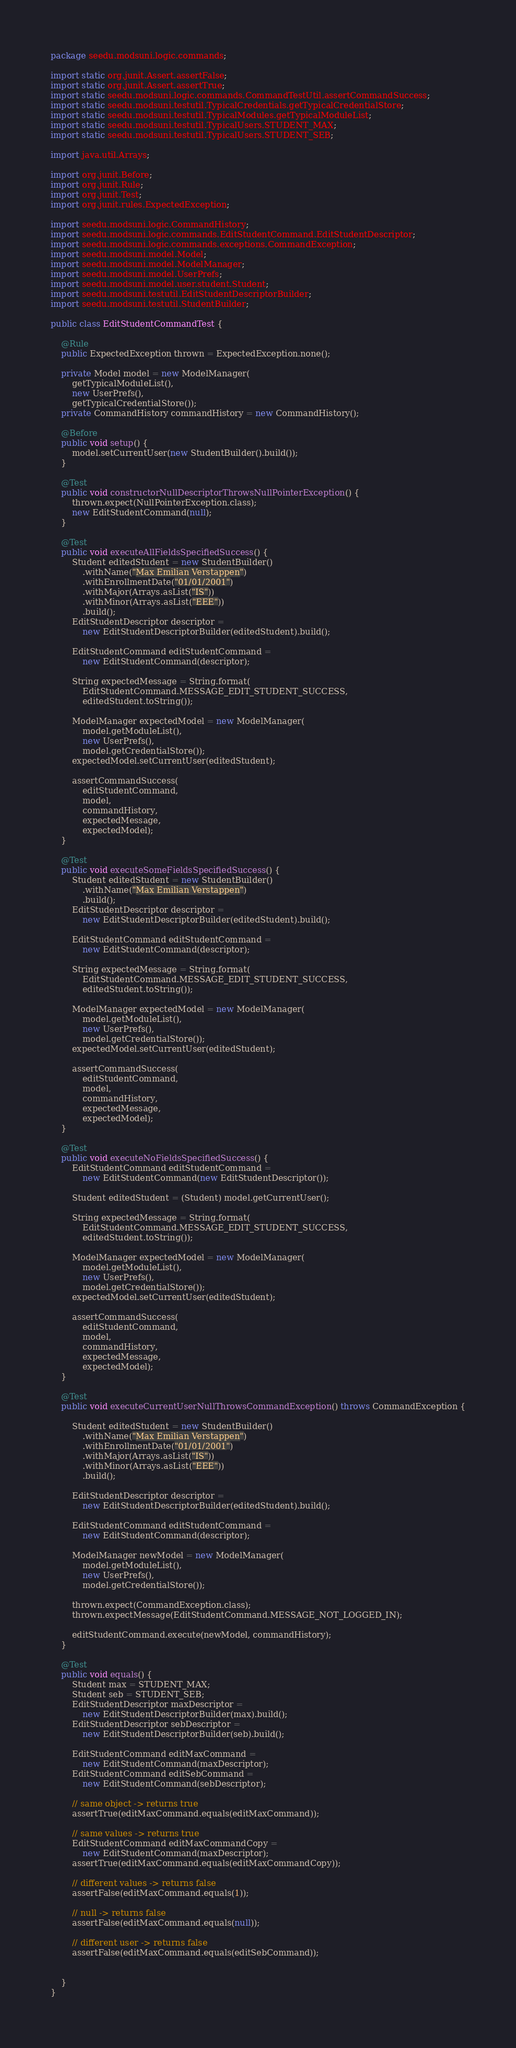Convert code to text. <code><loc_0><loc_0><loc_500><loc_500><_Java_>package seedu.modsuni.logic.commands;

import static org.junit.Assert.assertFalse;
import static org.junit.Assert.assertTrue;
import static seedu.modsuni.logic.commands.CommandTestUtil.assertCommandSuccess;
import static seedu.modsuni.testutil.TypicalCredentials.getTypicalCredentialStore;
import static seedu.modsuni.testutil.TypicalModules.getTypicalModuleList;
import static seedu.modsuni.testutil.TypicalUsers.STUDENT_MAX;
import static seedu.modsuni.testutil.TypicalUsers.STUDENT_SEB;

import java.util.Arrays;

import org.junit.Before;
import org.junit.Rule;
import org.junit.Test;
import org.junit.rules.ExpectedException;

import seedu.modsuni.logic.CommandHistory;
import seedu.modsuni.logic.commands.EditStudentCommand.EditStudentDescriptor;
import seedu.modsuni.logic.commands.exceptions.CommandException;
import seedu.modsuni.model.Model;
import seedu.modsuni.model.ModelManager;
import seedu.modsuni.model.UserPrefs;
import seedu.modsuni.model.user.student.Student;
import seedu.modsuni.testutil.EditStudentDescriptorBuilder;
import seedu.modsuni.testutil.StudentBuilder;

public class EditStudentCommandTest {

    @Rule
    public ExpectedException thrown = ExpectedException.none();

    private Model model = new ModelManager(
        getTypicalModuleList(),
        new UserPrefs(),
        getTypicalCredentialStore());
    private CommandHistory commandHistory = new CommandHistory();

    @Before
    public void setup() {
        model.setCurrentUser(new StudentBuilder().build());
    }

    @Test
    public void constructorNullDescriptorThrowsNullPointerException() {
        thrown.expect(NullPointerException.class);
        new EditStudentCommand(null);
    }

    @Test
    public void executeAllFieldsSpecifiedSuccess() {
        Student editedStudent = new StudentBuilder()
            .withName("Max Emilian Verstappen")
            .withEnrollmentDate("01/01/2001")
            .withMajor(Arrays.asList("IS"))
            .withMinor(Arrays.asList("EEE"))
            .build();
        EditStudentDescriptor descriptor =
            new EditStudentDescriptorBuilder(editedStudent).build();

        EditStudentCommand editStudentCommand =
            new EditStudentCommand(descriptor);

        String expectedMessage = String.format(
            EditStudentCommand.MESSAGE_EDIT_STUDENT_SUCCESS,
            editedStudent.toString());

        ModelManager expectedModel = new ModelManager(
            model.getModuleList(),
            new UserPrefs(),
            model.getCredentialStore());
        expectedModel.setCurrentUser(editedStudent);

        assertCommandSuccess(
            editStudentCommand,
            model,
            commandHistory,
            expectedMessage,
            expectedModel);
    }

    @Test
    public void executeSomeFieldsSpecifiedSuccess() {
        Student editedStudent = new StudentBuilder()
            .withName("Max Emilian Verstappen")
            .build();
        EditStudentDescriptor descriptor =
            new EditStudentDescriptorBuilder(editedStudent).build();

        EditStudentCommand editStudentCommand =
            new EditStudentCommand(descriptor);

        String expectedMessage = String.format(
            EditStudentCommand.MESSAGE_EDIT_STUDENT_SUCCESS,
            editedStudent.toString());

        ModelManager expectedModel = new ModelManager(
            model.getModuleList(),
            new UserPrefs(),
            model.getCredentialStore());
        expectedModel.setCurrentUser(editedStudent);

        assertCommandSuccess(
            editStudentCommand,
            model,
            commandHistory,
            expectedMessage,
            expectedModel);
    }

    @Test
    public void executeNoFieldsSpecifiedSuccess() {
        EditStudentCommand editStudentCommand =
            new EditStudentCommand(new EditStudentDescriptor());

        Student editedStudent = (Student) model.getCurrentUser();

        String expectedMessage = String.format(
            EditStudentCommand.MESSAGE_EDIT_STUDENT_SUCCESS,
            editedStudent.toString());

        ModelManager expectedModel = new ModelManager(
            model.getModuleList(),
            new UserPrefs(),
            model.getCredentialStore());
        expectedModel.setCurrentUser(editedStudent);

        assertCommandSuccess(
            editStudentCommand,
            model,
            commandHistory,
            expectedMessage,
            expectedModel);
    }

    @Test
    public void executeCurrentUserNullThrowsCommandException() throws CommandException {

        Student editedStudent = new StudentBuilder()
            .withName("Max Emilian Verstappen")
            .withEnrollmentDate("01/01/2001")
            .withMajor(Arrays.asList("IS"))
            .withMinor(Arrays.asList("EEE"))
            .build();

        EditStudentDescriptor descriptor =
            new EditStudentDescriptorBuilder(editedStudent).build();

        EditStudentCommand editStudentCommand =
            new EditStudentCommand(descriptor);

        ModelManager newModel = new ModelManager(
            model.getModuleList(),
            new UserPrefs(),
            model.getCredentialStore());

        thrown.expect(CommandException.class);
        thrown.expectMessage(EditStudentCommand.MESSAGE_NOT_LOGGED_IN);

        editStudentCommand.execute(newModel, commandHistory);
    }

    @Test
    public void equals() {
        Student max = STUDENT_MAX;
        Student seb = STUDENT_SEB;
        EditStudentDescriptor maxDescriptor =
            new EditStudentDescriptorBuilder(max).build();
        EditStudentDescriptor sebDescriptor =
            new EditStudentDescriptorBuilder(seb).build();

        EditStudentCommand editMaxCommand =
            new EditStudentCommand(maxDescriptor);
        EditStudentCommand editSebCommand =
            new EditStudentCommand(sebDescriptor);

        // same object -> returns true
        assertTrue(editMaxCommand.equals(editMaxCommand));

        // same values -> returns true
        EditStudentCommand editMaxCommandCopy =
            new EditStudentCommand(maxDescriptor);
        assertTrue(editMaxCommand.equals(editMaxCommandCopy));

        // different values -> returns false
        assertFalse(editMaxCommand.equals(1));

        // null -> returns false
        assertFalse(editMaxCommand.equals(null));

        // different user -> returns false
        assertFalse(editMaxCommand.equals(editSebCommand));


    }
}
</code> 